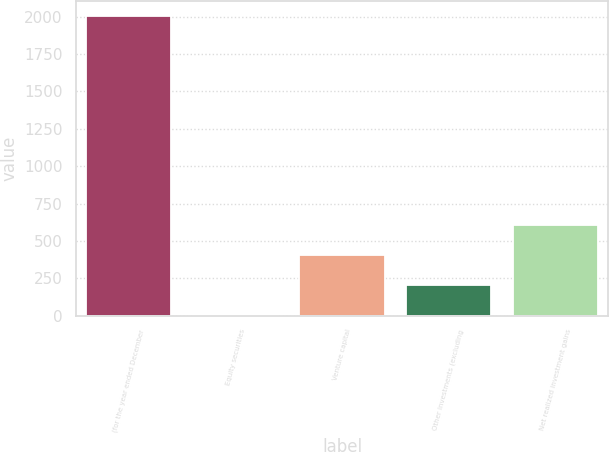Convert chart to OTSL. <chart><loc_0><loc_0><loc_500><loc_500><bar_chart><fcel>(for the year ended December<fcel>Equity securities<fcel>Venture capital<fcel>Other investments (excluding<fcel>Net realized investment gains<nl><fcel>2007<fcel>2<fcel>403<fcel>202.5<fcel>603.5<nl></chart> 